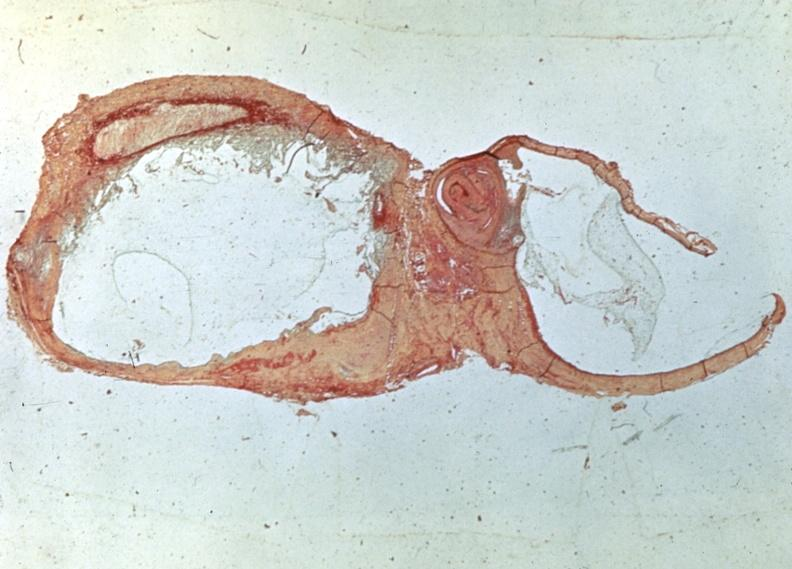what does this image show?
Answer the question using a single word or phrase. Popliteal cyst myxoid 